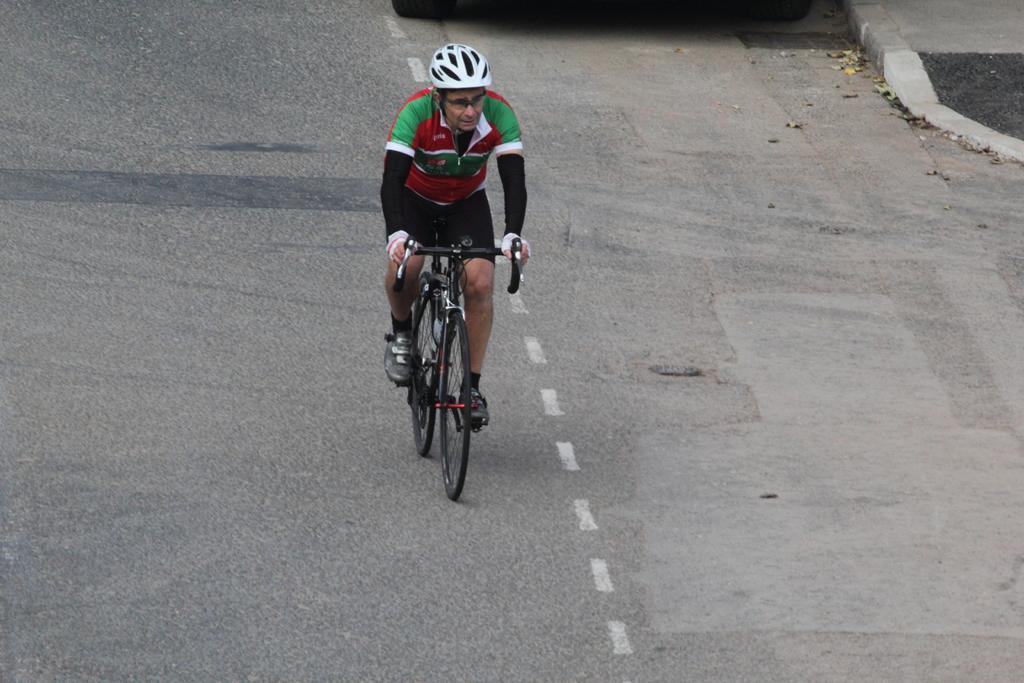Can you describe this image briefly? In the center of the image we can see a man riding a bicycle on the road. 